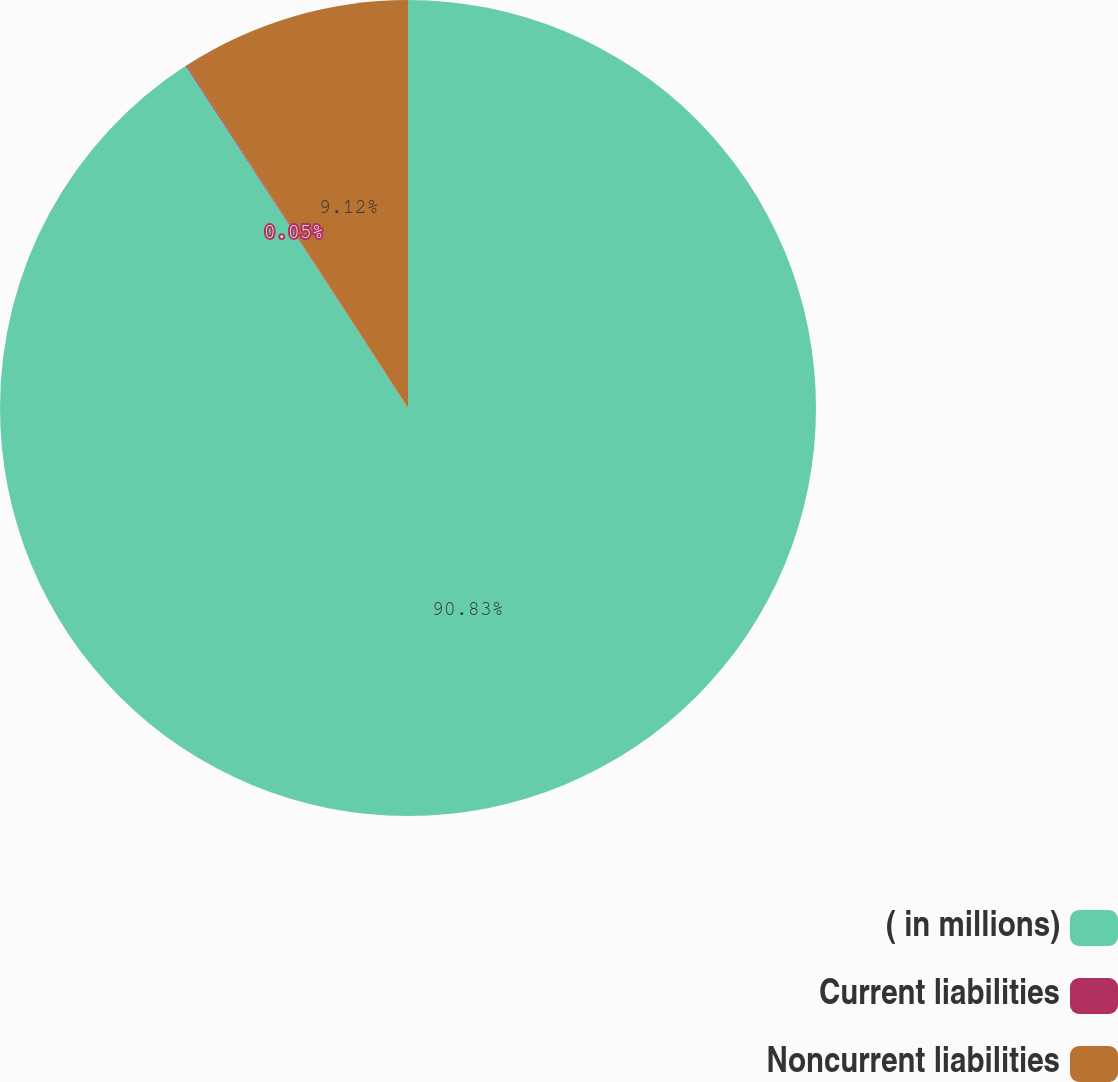<chart> <loc_0><loc_0><loc_500><loc_500><pie_chart><fcel>( in millions)<fcel>Current liabilities<fcel>Noncurrent liabilities<nl><fcel>90.83%<fcel>0.05%<fcel>9.12%<nl></chart> 